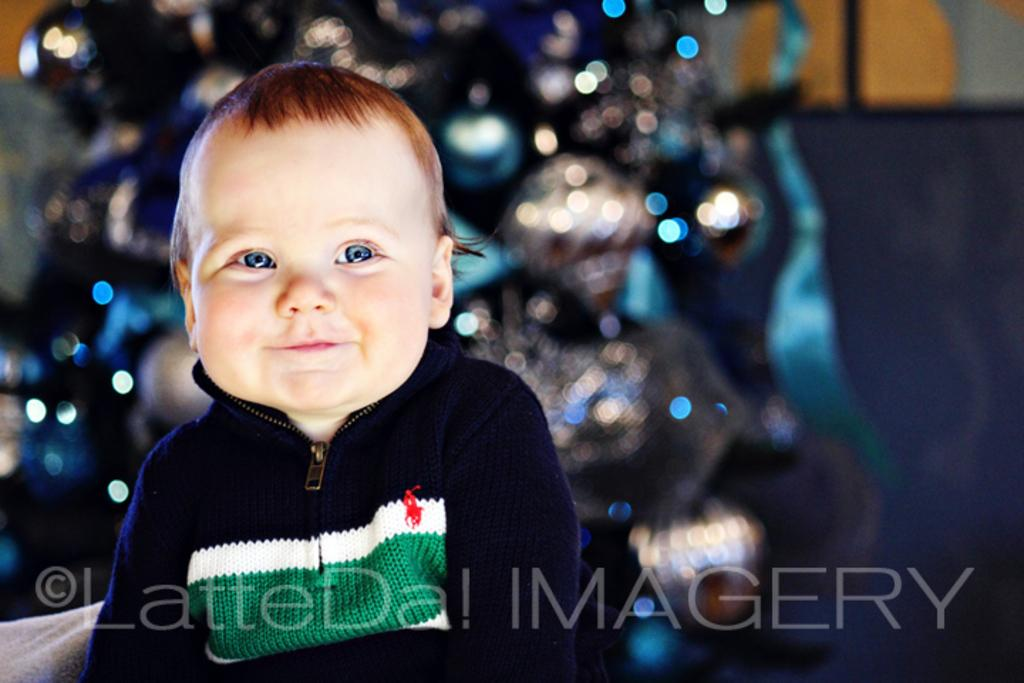What is the main subject in the foreground of the image? There is a small baby in the foreground of the image. What else can be seen in the foreground of the image? There is text in the foreground of the image. How would you describe the background of the image? The background of the image is blurry. How many people are shaking hands in the image? There are no people shaking hands in the image; it features a small baby and text in the foreground. What type of railway is visible in the image? There is no railway present in the image. 